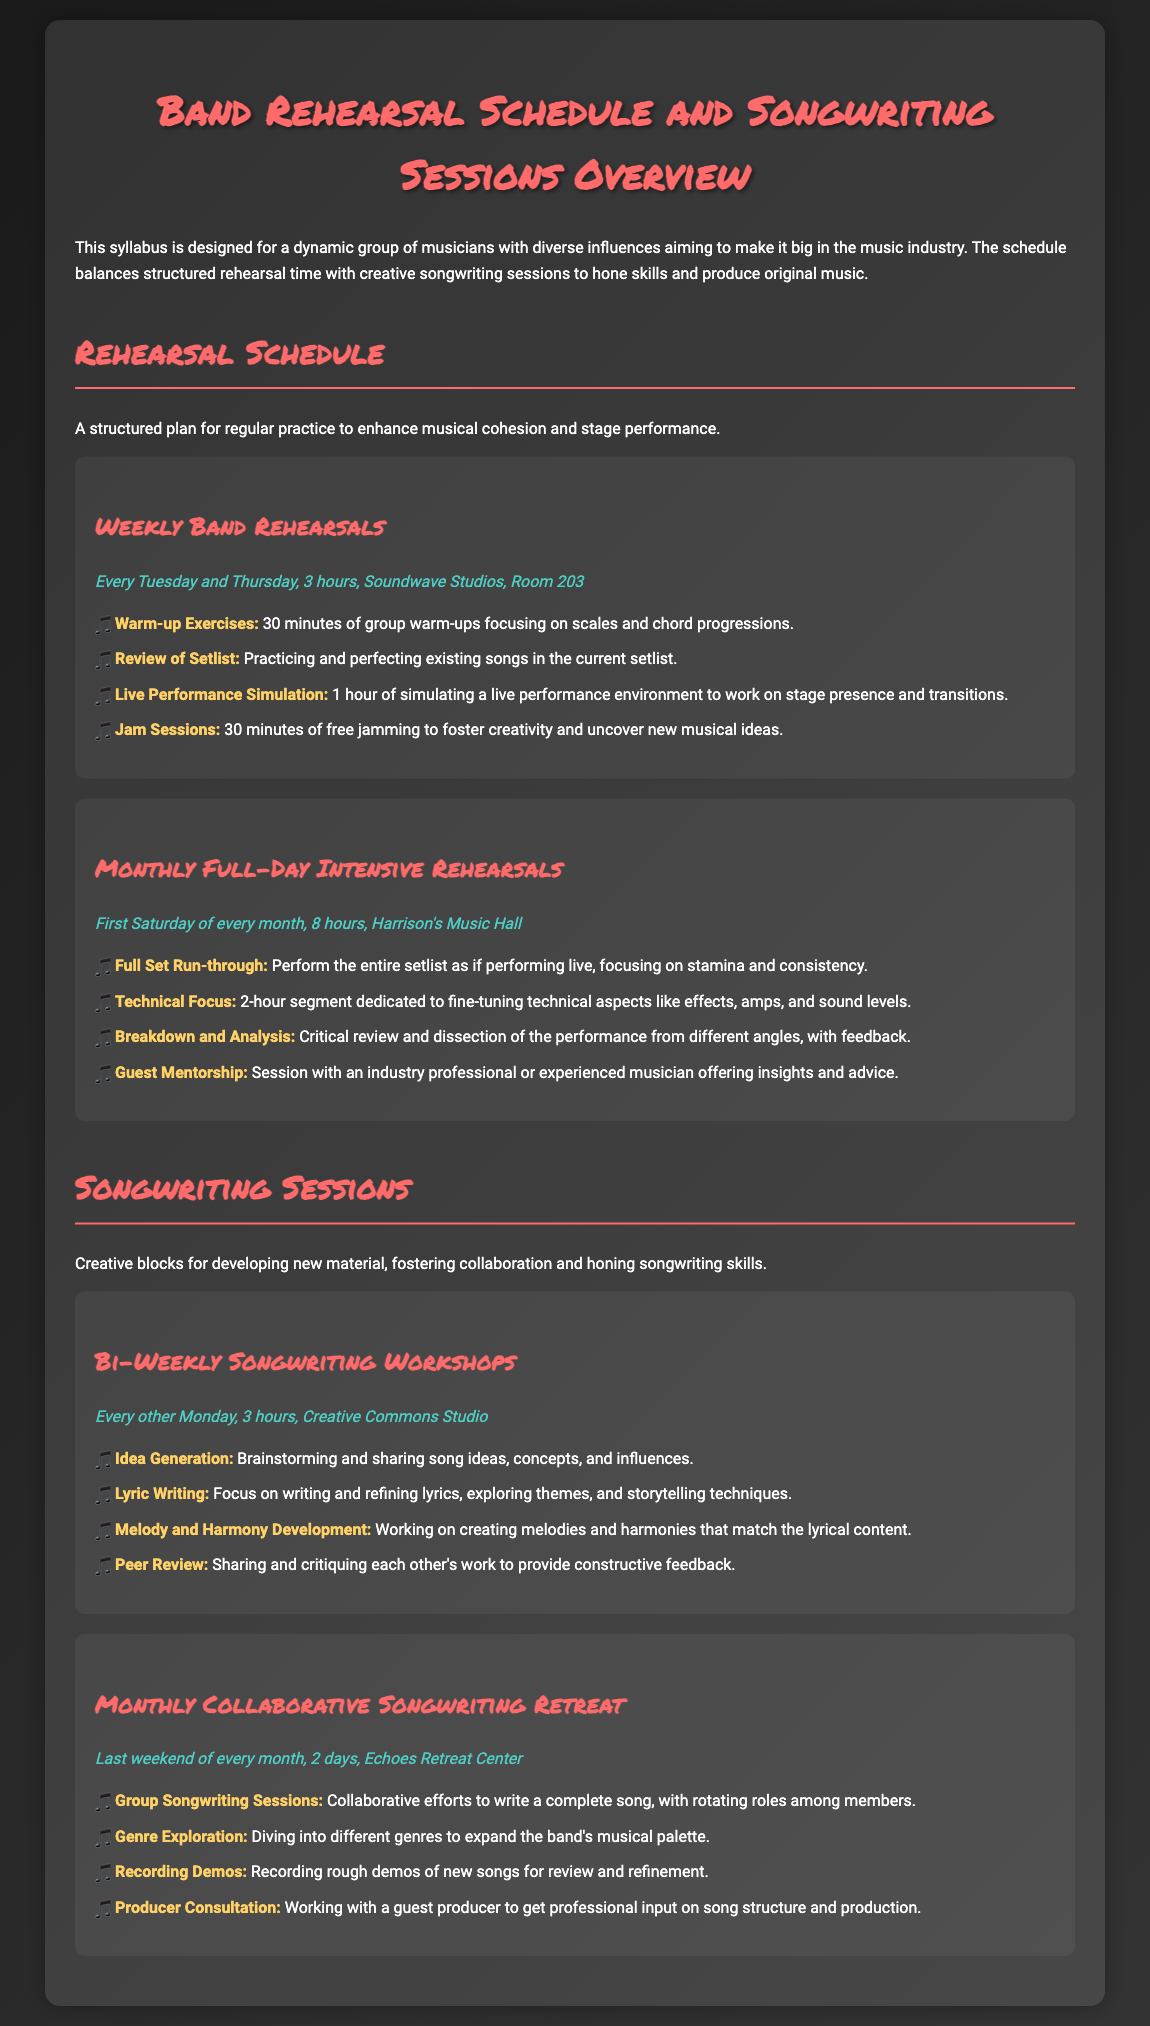What day of the week are the weekly band rehearsals held? The weekly band rehearsals are conducted every Tuesday and Thursday.
Answer: Tuesday and Thursday How long is each weekly band rehearsal session? Each weekly band rehearsal lasts for 3 hours.
Answer: 3 hours Where do the monthly full-day intensive rehearsals take place? The monthly full-day intensive rehearsals are held at Harrison's Music Hall.
Answer: Harrison's Music Hall What is the focus of the 2-hour segment during the monthly full-day intensive rehearsals? It is dedicated to fine-tuning technical aspects like effects, amps, and sound levels.
Answer: Technical Focus How frequently do the bi-weekly songwriting workshops occur? The bi-weekly songwriting workshops occur every other Monday.
Answer: Every other Monday What is a primary activity during the monthly collaborative songwriting retreat? A primary activity is group songwriting sessions, creating a complete song with rotating roles.
Answer: Group Songwriting Sessions What is the duration of the monthly collaborative songwriting retreat? The monthly collaborative songwriting retreat lasts for 2 days.
Answer: 2 days Which studio hosts the bi-weekly songwriting workshops? The bi-weekly songwriting workshops are held at Creative Commons Studio.
Answer: Creative Commons Studio What specific purpose do the peer review sessions serve during the songwriting workshops? The peer review sessions are for sharing and critiquing each other's work.
Answer: Sharing and critiquing work 